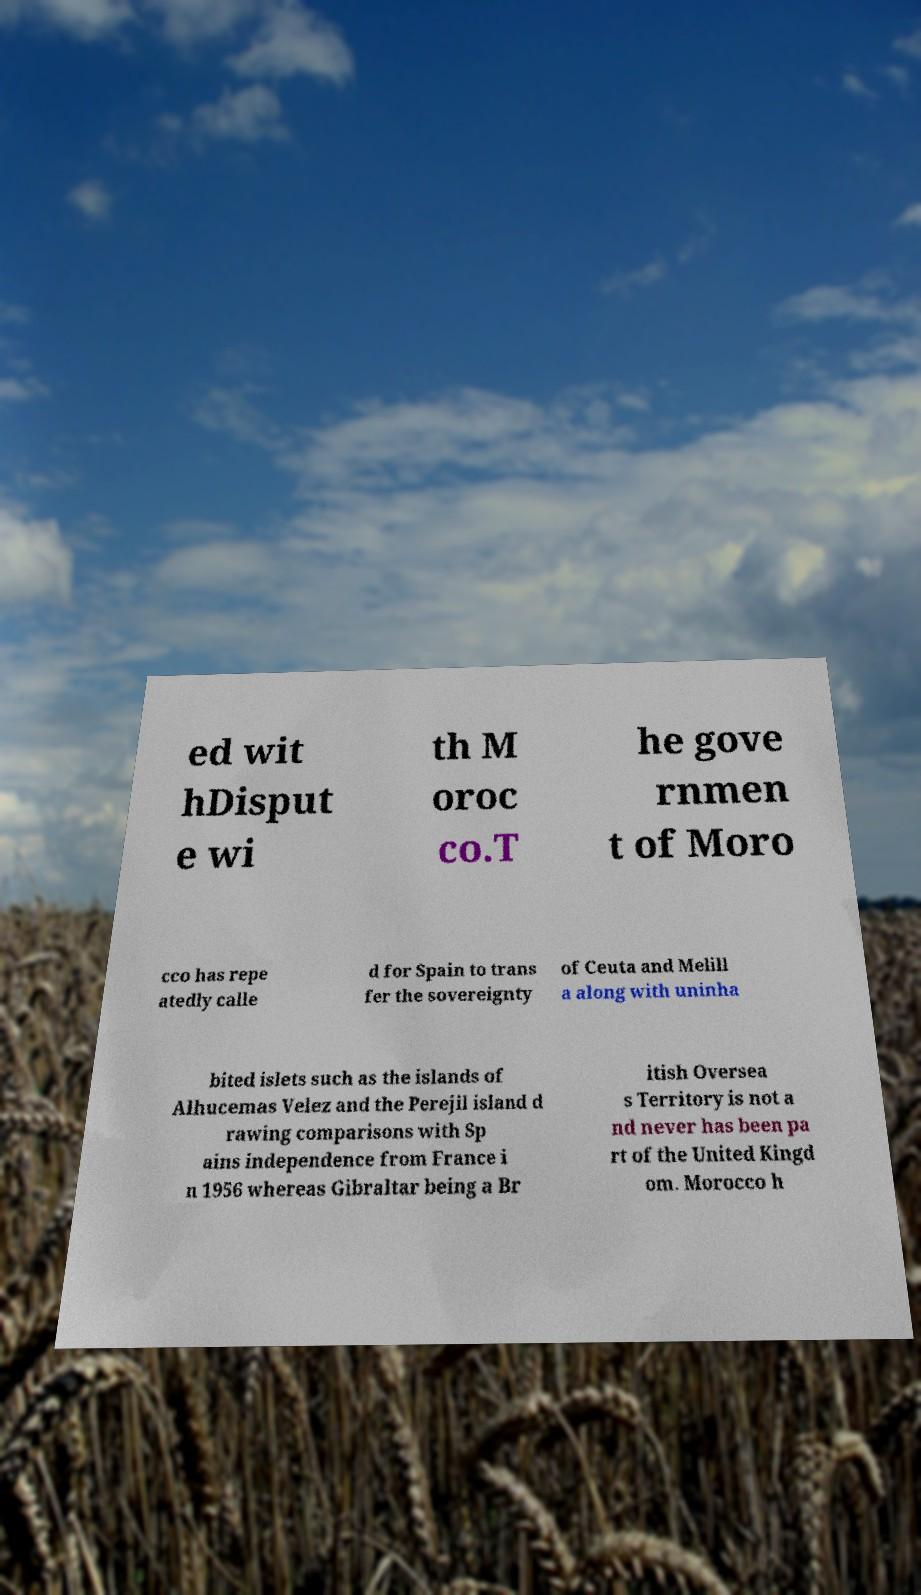Please read and relay the text visible in this image. What does it say? ed wit hDisput e wi th M oroc co.T he gove rnmen t of Moro cco has repe atedly calle d for Spain to trans fer the sovereignty of Ceuta and Melill a along with uninha bited islets such as the islands of Alhucemas Velez and the Perejil island d rawing comparisons with Sp ains independence from France i n 1956 whereas Gibraltar being a Br itish Oversea s Territory is not a nd never has been pa rt of the United Kingd om. Morocco h 